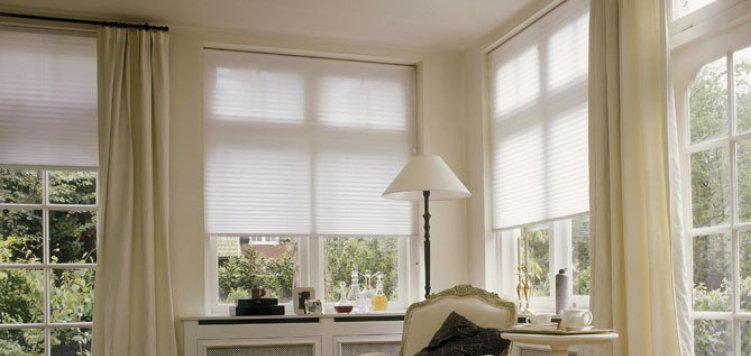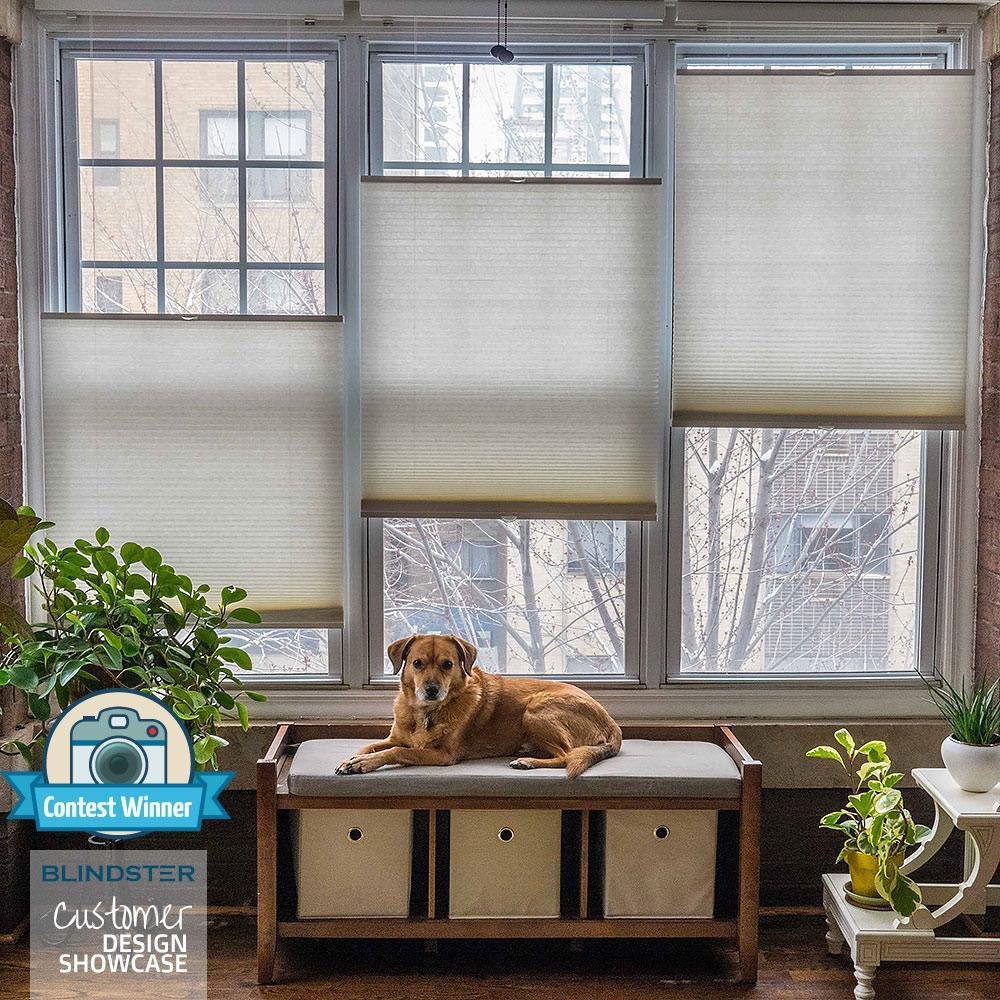The first image is the image on the left, the second image is the image on the right. Given the left and right images, does the statement "There are the same number of windows in both images." hold true? Answer yes or no. No. The first image is the image on the left, the second image is the image on the right. Examine the images to the left and right. Is the description "There are five to six shades." accurate? Answer yes or no. Yes. 